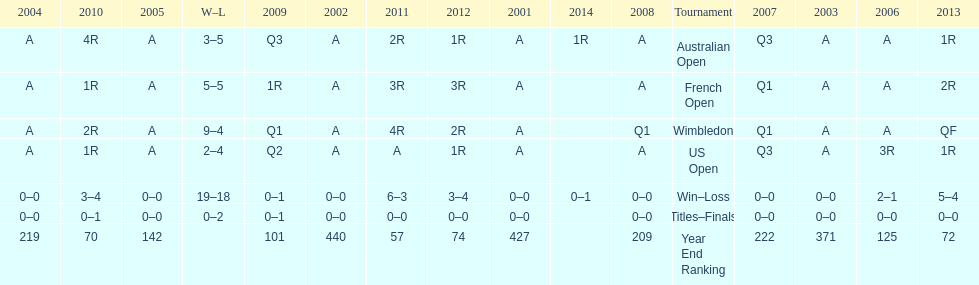What is the difference in wins between wimbledon and the us open for this player? 7. 